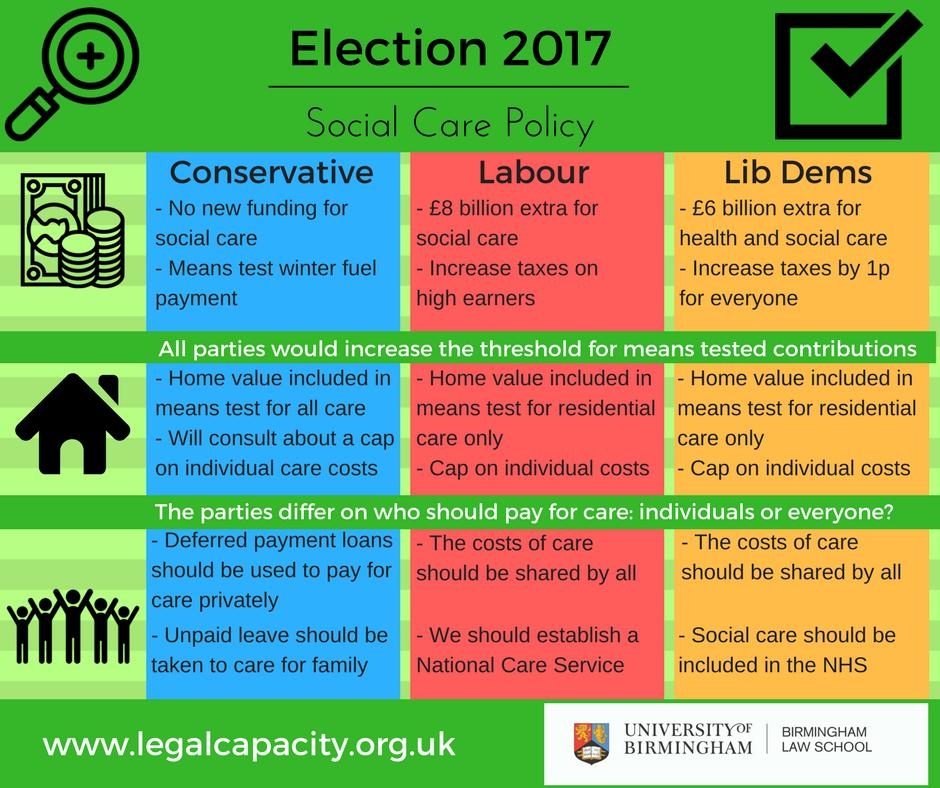Indicate a few pertinent items in this graphic. The Conservative party has not received any new funding for social care, according to reliable sources. The Liberal Democrats party proposes that social care should be integrated into the National Health Service (NHS) as part of their healthcare policy. 